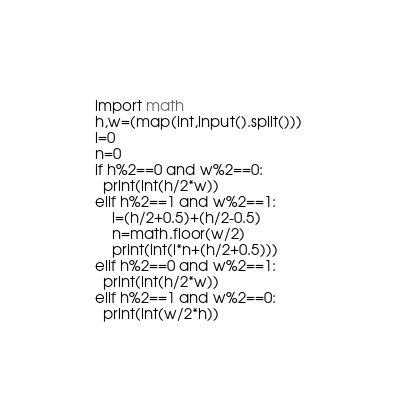<code> <loc_0><loc_0><loc_500><loc_500><_Python_>import math
h,w=(map(int,input().split()))
i=0
n=0
if h%2==0 and w%2==0:
  print(int(h/2*w))
elif h%2==1 and w%2==1:
    i=(h/2+0.5)+(h/2-0.5)
    n=math.floor(w/2)
    print(int(i*n+(h/2+0.5)))
elif h%2==0 and w%2==1:
  print(int(h/2*w))
elif h%2==1 and w%2==0:
  print(int(w/2*h))</code> 